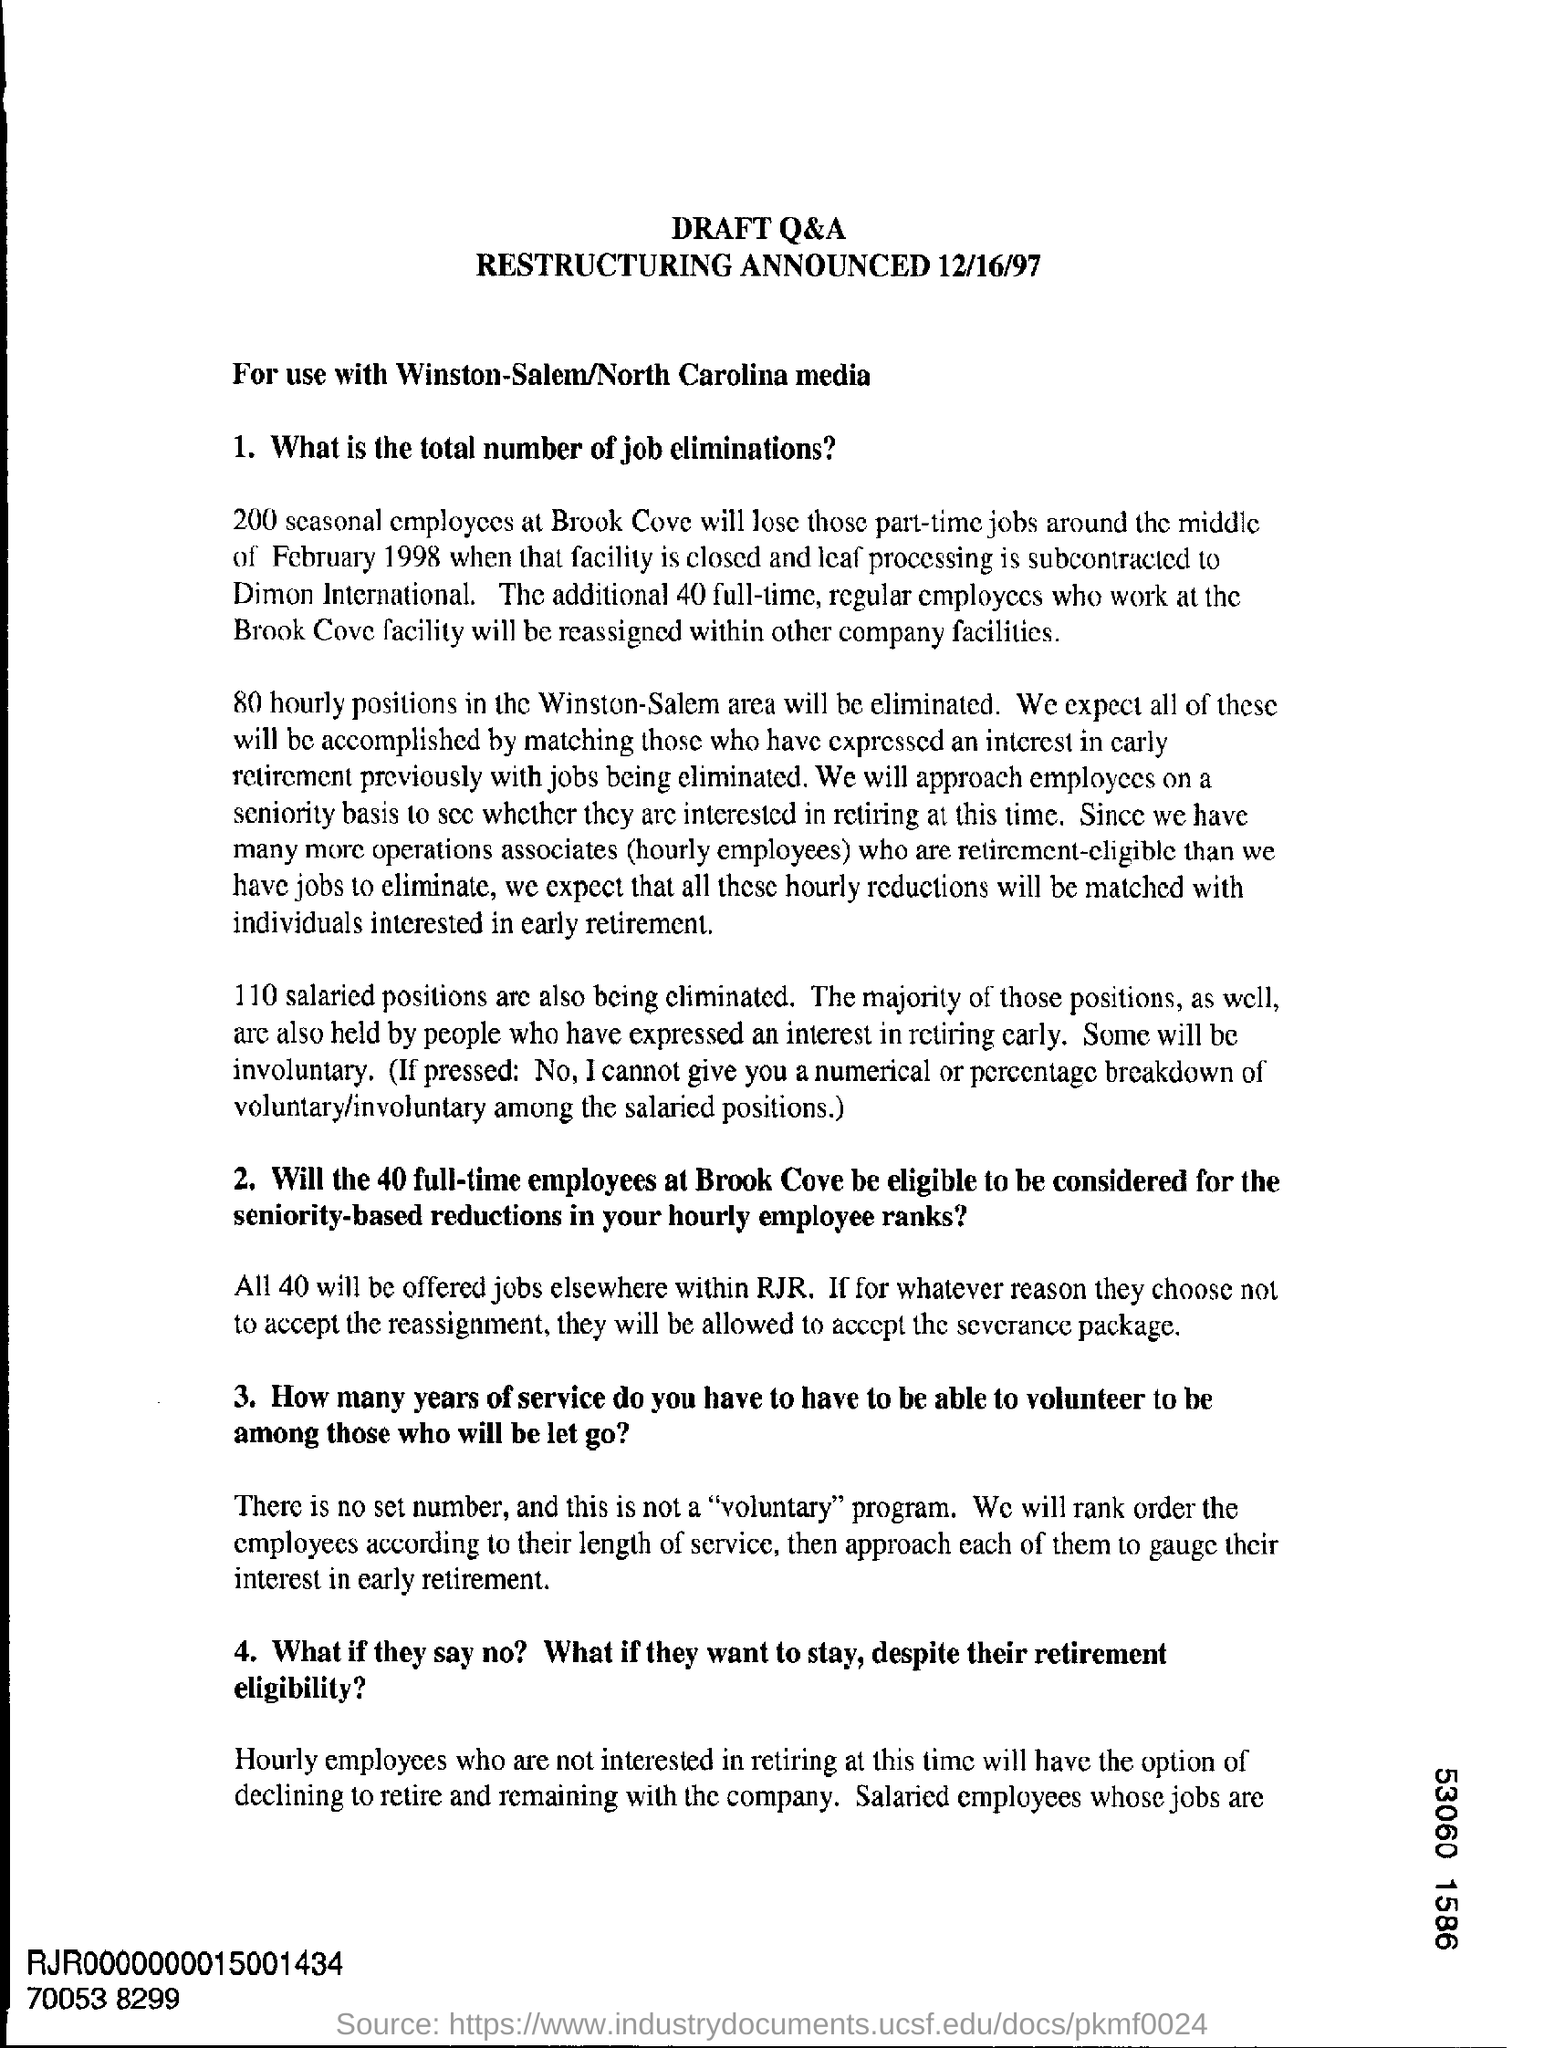How many seasonal employees will lose those part time jobs around middle of february 1998?
Your answer should be very brief. 200. What is the heading at top of the page ?
Offer a very short reply. Draft Q&A. On what date is the restructuring announced ?
Provide a succinct answer. 12/16/97. 